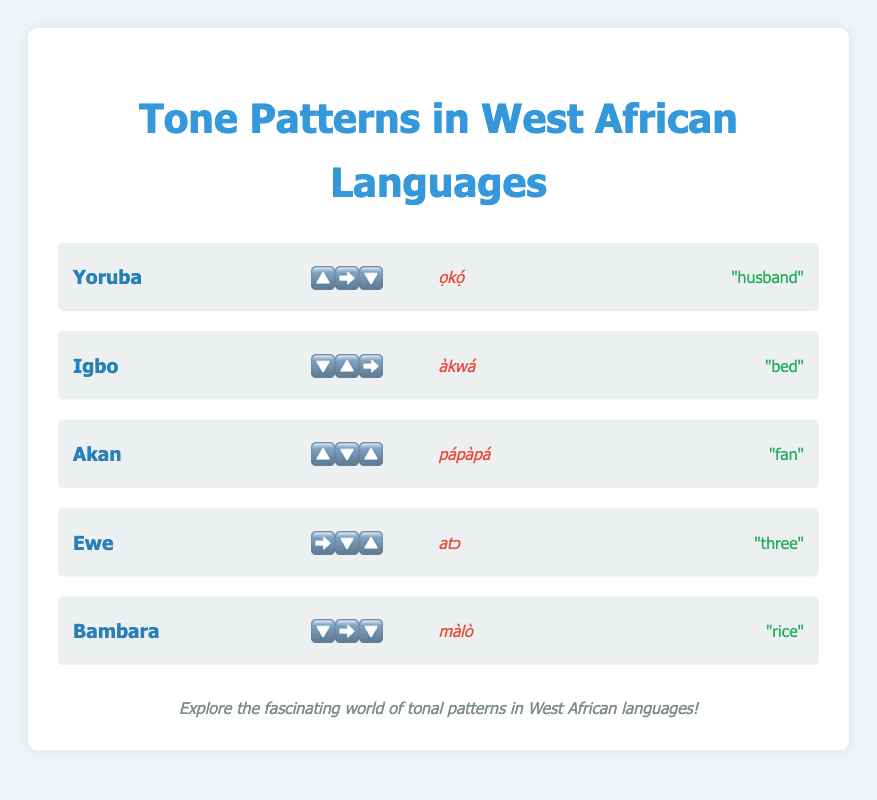What is the tone pattern of Yoruba? The tone pattern of Yoruba is represented visually by emojis in the figure. By looking at the row corresponding to Yoruba, you can see the sequence is 🔼➡️🔽.
Answer: 🔼➡️🔽 Which language has the tone pattern "🔽🔼➡️"? To find the language with the tone pattern "🔽🔼➡️", scan through the tone patterns for each language. The language with this tone pattern is Igbo, as shown in the figure.
Answer: Igbo What example word and meaning are given for Akan? Locate the row with Akan, and immediately to the right of the language name you'll find the example word and its meaning. The example word for Akan is "pápàpá", and it means "fan".
Answer: pápàpá, "fan" How many languages have a tone pattern starting with a downward emoji (🔽)? Check each tone pattern in the figure to see which ones start with 🔽. Igbo and Bambara meet this criterion.
Answer: 2 Compare the tone patterns of Yoruba and Ewe. Which have more vertical movements (up or down)? Yoruba's tone pattern is 🔼➡️🔽, and Ewe's is ➡️🔽🔼. Yoruba has two vertical movements (up and down), while Ewe also has two vertical movements (down and up). Both have the same number of vertical movements.
Answer: Both have the same Which language's tone pattern has an upward emoji (🔼) followed by a downward emoji (🔽)? Identify the language that has the sequence 🔼 followed by 🔽 in its tone pattern. Akan's tone pattern, 🔼🔽🔼, has these emojis in sequence.
Answer: Akan What's the meaning of the Igbo word "àkwá"? Find the example word for Igbo in the figure and look right next to it for its meaning. The Igbo word "àkwá" means "bed".
Answer: "bed" How many languages have a flat tone (➡️) in their pattern? Look for the flat tone emoji (➡️) in each language's tone pattern. Yoruba, Igbo, Ewe, and Bambara include it in their tone patterns.
Answer: 4 